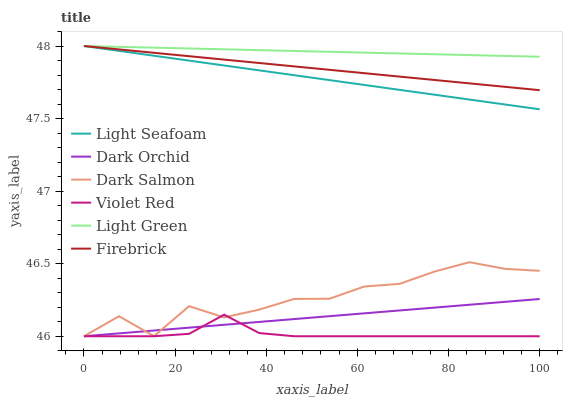Does Violet Red have the minimum area under the curve?
Answer yes or no. Yes. Does Light Green have the maximum area under the curve?
Answer yes or no. Yes. Does Firebrick have the minimum area under the curve?
Answer yes or no. No. Does Firebrick have the maximum area under the curve?
Answer yes or no. No. Is Light Green the smoothest?
Answer yes or no. Yes. Is Dark Salmon the roughest?
Answer yes or no. Yes. Is Firebrick the smoothest?
Answer yes or no. No. Is Firebrick the roughest?
Answer yes or no. No. Does Violet Red have the lowest value?
Answer yes or no. Yes. Does Firebrick have the lowest value?
Answer yes or no. No. Does Light Seafoam have the highest value?
Answer yes or no. Yes. Does Dark Salmon have the highest value?
Answer yes or no. No. Is Dark Salmon less than Light Green?
Answer yes or no. Yes. Is Light Green greater than Violet Red?
Answer yes or no. Yes. Does Light Seafoam intersect Light Green?
Answer yes or no. Yes. Is Light Seafoam less than Light Green?
Answer yes or no. No. Is Light Seafoam greater than Light Green?
Answer yes or no. No. Does Dark Salmon intersect Light Green?
Answer yes or no. No. 